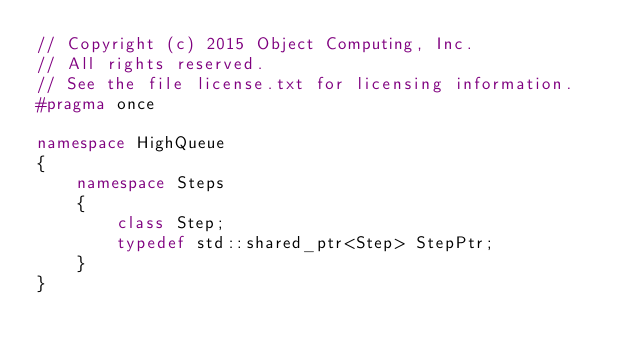<code> <loc_0><loc_0><loc_500><loc_500><_C++_>// Copyright (c) 2015 Object Computing, Inc.
// All rights reserved.
// See the file license.txt for licensing information.
#pragma once

namespace HighQueue
{
    namespace Steps
    {
        class Step;
        typedef std::shared_ptr<Step> StepPtr;
    }
}</code> 